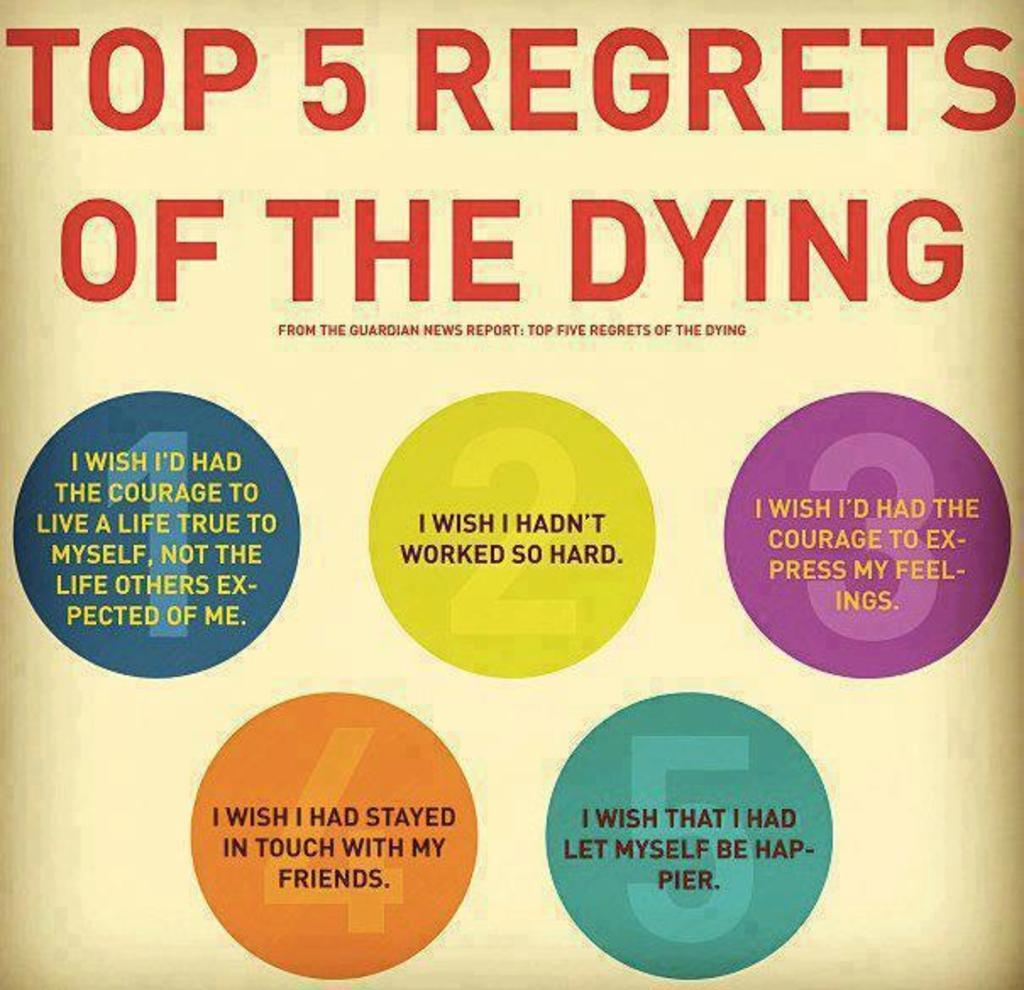What is present on the paper in the image? There is text on a paper in the image. Can you describe the text on the paper? Unfortunately, the specific content of the text cannot be determined from the image alone. What might the text on the paper be related to? It is impossible to determine the subject matter of the text without additional context. What type of voice can be heard coming from the grandfather in the image? There is no grandfather or voice present in the image; it only features text on a paper. 